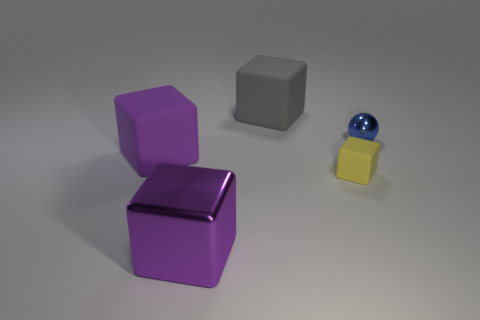Are the gray thing and the large purple thing that is to the left of the large purple metal thing made of the same material?
Offer a terse response. Yes. What is the size of the gray matte thing that is the same shape as the purple shiny thing?
Your answer should be compact. Large. What is the material of the small yellow cube?
Provide a short and direct response. Rubber. There is a gray thing that is behind the large purple rubber block that is in front of the shiny object behind the purple metallic cube; what is its material?
Provide a short and direct response. Rubber. There is a metal thing behind the purple shiny cube; is its size the same as the cube that is on the right side of the big gray object?
Ensure brevity in your answer.  Yes. How many other objects are the same material as the gray block?
Provide a short and direct response. 2. How many shiny objects are large cubes or small brown cylinders?
Make the answer very short. 1. Are there fewer blue metal objects than tiny blue matte things?
Make the answer very short. No. Does the blue thing have the same size as the purple object that is behind the tiny yellow object?
Offer a terse response. No. Is there anything else that has the same shape as the tiny yellow thing?
Provide a succinct answer. Yes. 